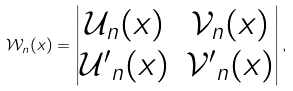Convert formula to latex. <formula><loc_0><loc_0><loc_500><loc_500>\mathcal { W } _ { n } ( x ) = \begin{vmatrix} \mathcal { U } _ { n } ( x ) & \mathcal { V } _ { n } ( x ) \\ \mathcal { U ^ { \prime } } _ { n } ( x ) & \mathcal { V ^ { \prime } } _ { n } ( x ) \end{vmatrix} ,</formula> 